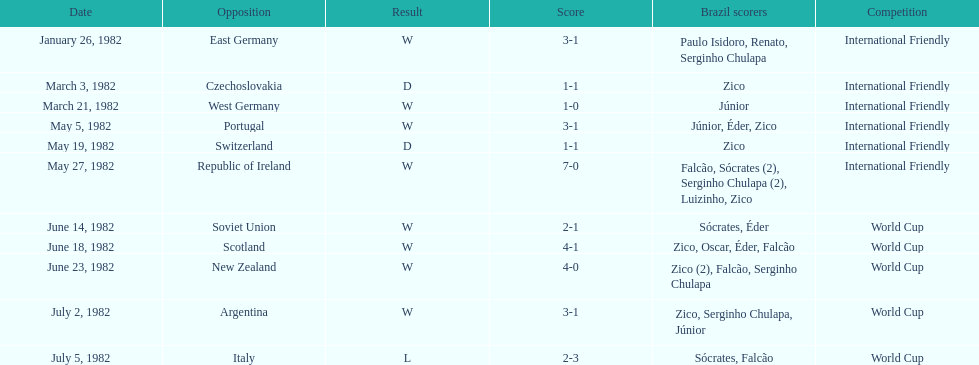Did brazil score more goals against the soviet union or portugal in 1982? Portugal. 